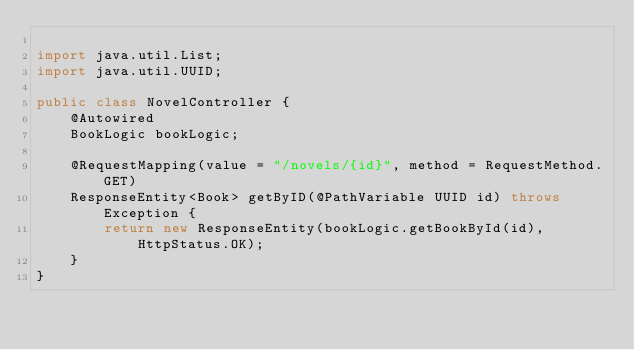Convert code to text. <code><loc_0><loc_0><loc_500><loc_500><_Java_>
import java.util.List;
import java.util.UUID;

public class NovelController {
    @Autowired
    BookLogic bookLogic;

    @RequestMapping(value = "/novels/{id}", method = RequestMethod.GET)
    ResponseEntity<Book> getByID(@PathVariable UUID id) throws Exception {
        return new ResponseEntity(bookLogic.getBookById(id), HttpStatus.OK);
    }
}
</code> 